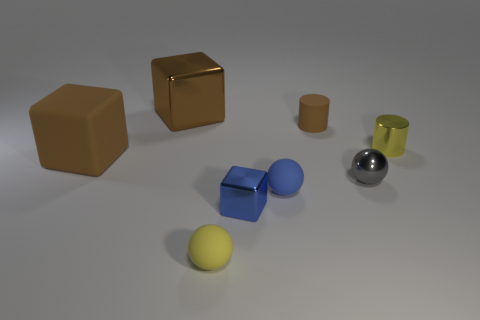Add 2 cyan metallic cylinders. How many objects exist? 10 Subtract all cylinders. How many objects are left? 6 Add 1 blocks. How many blocks exist? 4 Subtract 2 brown blocks. How many objects are left? 6 Subtract all small gray objects. Subtract all tiny yellow metallic objects. How many objects are left? 6 Add 4 tiny blue rubber balls. How many tiny blue rubber balls are left? 5 